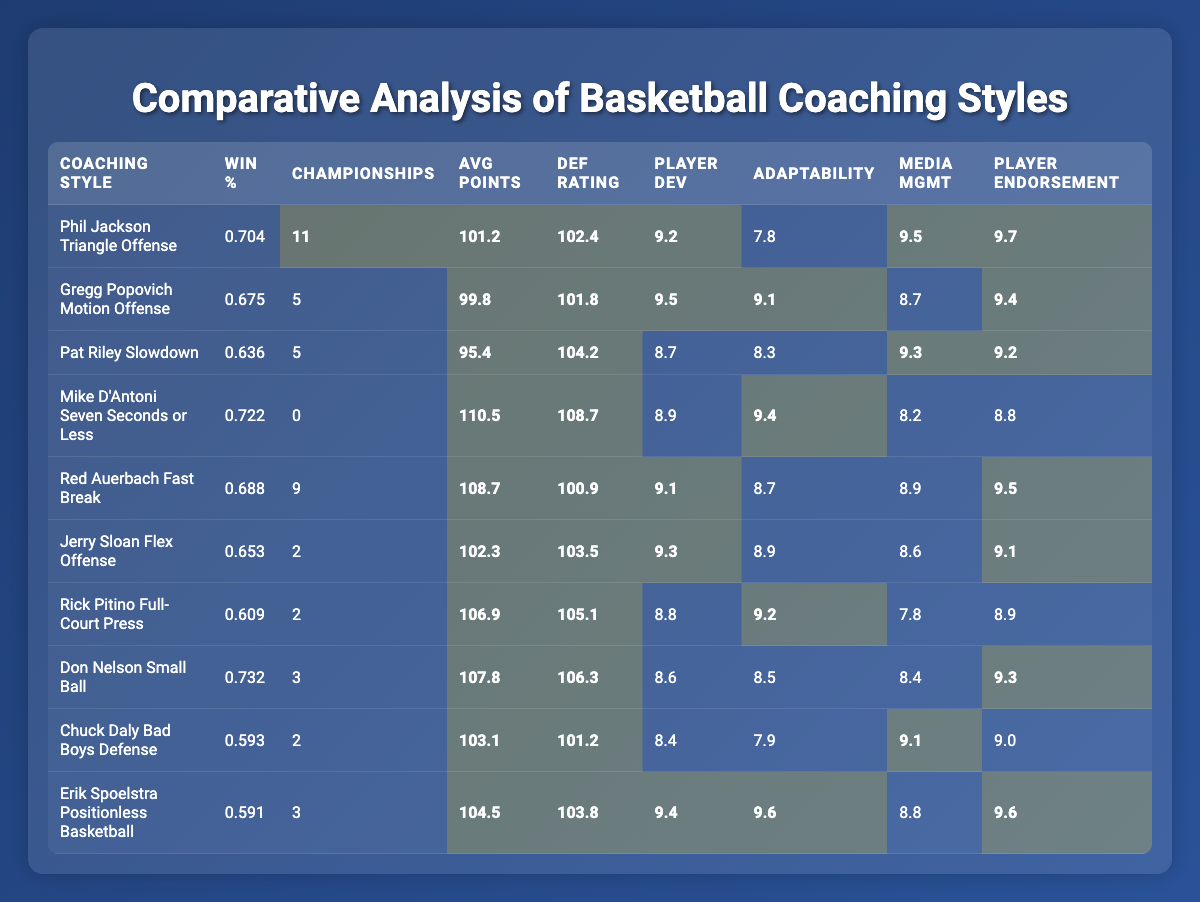What is the win percentage of Phil Jackson's Triangle Offense? The table shows Phil Jackson's Triangle Offense win percentage listed under "Win %," which is 0.704.
Answer: 0.704 Which coaching style has the highest number of championships won? By reviewing the "Championships" column, Phil Jackson's Triangle Offense has the highest number, totaling 11 championships.
Answer: 11 What is the average points per game for Jerry Sloan's Flex Offense? Referring to the "Avg Points" column for Jerry Sloan's Flex Offense, the average points per game is recorded as 102.3.
Answer: 102.3 How does Rick Pitino's Full-Court Press's defensive rating compare to Red Auerbach's Fast Break? Pitino's Full-Court Press has a defensive rating of 105.1 while Auerbach's Fast Break has a defensive rating of 100.9. Pitino's rating is higher by 4.2 (105.1 - 100.9).
Answer: 4.2 What is the difference between the win percentage of the 1990s and the 2000s coaching styles? The win percentage in the 1990s is 0.688 and in the 2000s it is 0.653. Calculating the difference: 0.688 - 0.653 = 0.035.
Answer: 0.035 Which coaching style from the 2000s has the lowest win percentage? Reviewing the table, Mike D'Antoni's Seven Seconds or Less from the 2000s has the lowest win percentage at 0.653.
Answer: 0.653 Is it true that the coach with the highest adaptability to rule changes also has the highest player development rating? Checking the values, Erik Spoelstra has the highest adaptability score of 9.6 but does not have the highest player development rating; Jerry Sloan has that at 9.3, thus the statement is false.
Answer: False Which era features the Slowdown coaching style and what is its average player development rating? The Slowdown coaching style belongs to the 1980s with a player development rating of 8.9.
Answer: 8.9 What is the average number of championships won across the coaching styles listed? To find the average, sum the total championships (11 + 5 + 5 + 0 + 9 + 2 + 2 + 3 + 2 + 3 = 42) and divide by the number of coaching styles (10), giving 42 / 10 = 4.2.
Answer: 4.2 Which coaching style scored the highest in both media management skill and player endorsement rating? Observing the table, Phil Jackson's Triangle Offense scored 9.5 in media management and 9.7 in player endorsement, making it the highest in both categories.
Answer: Phil Jackson's Triangle Offense 